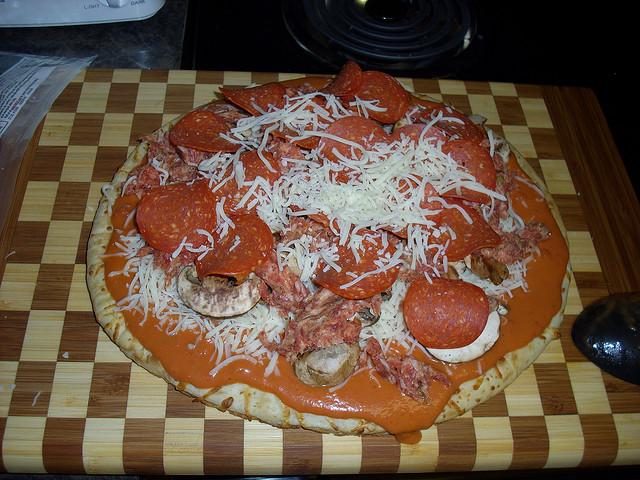Is this already to eat?
Keep it brief. No. What does that design on the plate look like?
Short answer required. Checkered. Does this pizza have tomato sauce?
Concise answer only. Yes. Is the pizza on a baking tray?
Write a very short answer. No. Is this a pepperoni pizza?
Concise answer only. Yes. What kind of table is the food on?
Keep it brief. Checkered. What are they preparing?
Answer briefly. Pizza. Does this appear to be a vegetarian dish?
Concise answer only. No. Would you sit here to eat dinner?
Give a very brief answer. Yes. What kind of cheese is on the pizza?
Short answer required. Mozzarella. What kind of food is this?
Answer briefly. Pizza. IS there broccoli on the pizza?
Quick response, please. No. What type of cheese was used on these pizzas?
Write a very short answer. Mozzarella. Is the pizza burnt?
Give a very brief answer. No. What topping are on the pizza?
Write a very short answer. Pepperoni and mushrooms. Is this a chocolate cake?
Give a very brief answer. No. Is the food cooked?
Keep it brief. No. What color is the mat?
Concise answer only. Brown. Is the pizza round?
Write a very short answer. Yes. Is this a pie or cake?
Short answer required. Pie. Would a vegan eat this pizza?
Keep it brief. No. Is the pizza hot?
Concise answer only. No. What are the toppings on the pizza?
Answer briefly. Pepperoni and mushroom. Is there pepperoni on the pizza?
Quick response, please. Yes. What kind of meat is this?
Keep it brief. Pepperoni. Does the food look healthy?
Answer briefly. No. What is the pizza on?
Answer briefly. Table. What is this box made of?
Give a very brief answer. Wood. What kind of cheese is the person grating?
Quick response, please. Mozzarella. What color are the tiles?
Quick response, please. Brown. 